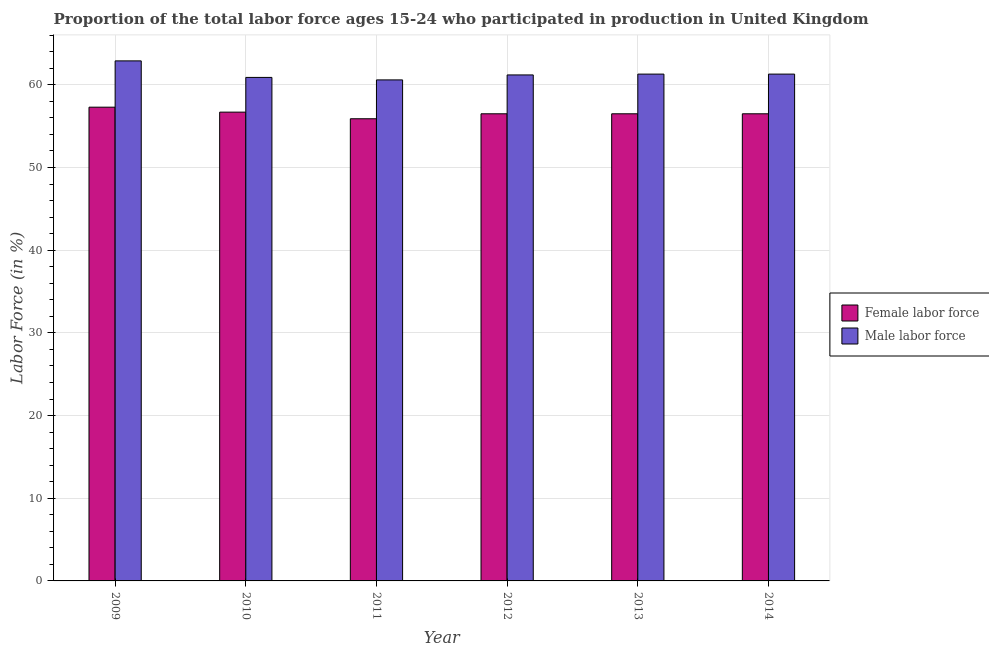How many different coloured bars are there?
Provide a short and direct response. 2. How many bars are there on the 2nd tick from the right?
Provide a short and direct response. 2. In how many cases, is the number of bars for a given year not equal to the number of legend labels?
Provide a succinct answer. 0. What is the percentage of male labour force in 2013?
Offer a very short reply. 61.3. Across all years, what is the maximum percentage of female labor force?
Your answer should be compact. 57.3. Across all years, what is the minimum percentage of female labor force?
Provide a succinct answer. 55.9. What is the total percentage of male labour force in the graph?
Give a very brief answer. 368.2. What is the difference between the percentage of male labour force in 2010 and that in 2013?
Provide a succinct answer. -0.4. What is the difference between the percentage of female labor force in 2011 and the percentage of male labour force in 2009?
Offer a terse response. -1.4. What is the average percentage of female labor force per year?
Keep it short and to the point. 56.57. What is the ratio of the percentage of female labor force in 2011 to that in 2012?
Provide a short and direct response. 0.99. Is the percentage of male labour force in 2009 less than that in 2012?
Provide a succinct answer. No. Is the difference between the percentage of female labor force in 2011 and 2014 greater than the difference between the percentage of male labour force in 2011 and 2014?
Keep it short and to the point. No. What is the difference between the highest and the second highest percentage of female labor force?
Offer a very short reply. 0.6. What is the difference between the highest and the lowest percentage of female labor force?
Your answer should be compact. 1.4. Is the sum of the percentage of female labor force in 2010 and 2011 greater than the maximum percentage of male labour force across all years?
Provide a succinct answer. Yes. What does the 1st bar from the left in 2010 represents?
Offer a very short reply. Female labor force. What does the 1st bar from the right in 2010 represents?
Your response must be concise. Male labor force. How many bars are there?
Make the answer very short. 12. What is the difference between two consecutive major ticks on the Y-axis?
Your response must be concise. 10. Where does the legend appear in the graph?
Ensure brevity in your answer.  Center right. How many legend labels are there?
Your answer should be very brief. 2. What is the title of the graph?
Offer a very short reply. Proportion of the total labor force ages 15-24 who participated in production in United Kingdom. Does "Lowest 20% of population" appear as one of the legend labels in the graph?
Offer a very short reply. No. What is the label or title of the X-axis?
Your answer should be compact. Year. What is the Labor Force (in %) of Female labor force in 2009?
Make the answer very short. 57.3. What is the Labor Force (in %) of Male labor force in 2009?
Make the answer very short. 62.9. What is the Labor Force (in %) of Female labor force in 2010?
Give a very brief answer. 56.7. What is the Labor Force (in %) in Male labor force in 2010?
Provide a succinct answer. 60.9. What is the Labor Force (in %) of Female labor force in 2011?
Your response must be concise. 55.9. What is the Labor Force (in %) of Male labor force in 2011?
Offer a terse response. 60.6. What is the Labor Force (in %) of Female labor force in 2012?
Provide a succinct answer. 56.5. What is the Labor Force (in %) of Male labor force in 2012?
Your answer should be very brief. 61.2. What is the Labor Force (in %) of Female labor force in 2013?
Ensure brevity in your answer.  56.5. What is the Labor Force (in %) of Male labor force in 2013?
Ensure brevity in your answer.  61.3. What is the Labor Force (in %) of Female labor force in 2014?
Offer a very short reply. 56.5. What is the Labor Force (in %) of Male labor force in 2014?
Ensure brevity in your answer.  61.3. Across all years, what is the maximum Labor Force (in %) in Female labor force?
Offer a very short reply. 57.3. Across all years, what is the maximum Labor Force (in %) of Male labor force?
Provide a succinct answer. 62.9. Across all years, what is the minimum Labor Force (in %) of Female labor force?
Make the answer very short. 55.9. Across all years, what is the minimum Labor Force (in %) of Male labor force?
Your response must be concise. 60.6. What is the total Labor Force (in %) in Female labor force in the graph?
Provide a succinct answer. 339.4. What is the total Labor Force (in %) in Male labor force in the graph?
Provide a succinct answer. 368.2. What is the difference between the Labor Force (in %) of Female labor force in 2009 and that in 2010?
Your response must be concise. 0.6. What is the difference between the Labor Force (in %) in Male labor force in 2009 and that in 2010?
Your answer should be compact. 2. What is the difference between the Labor Force (in %) of Male labor force in 2009 and that in 2011?
Keep it short and to the point. 2.3. What is the difference between the Labor Force (in %) of Female labor force in 2009 and that in 2014?
Make the answer very short. 0.8. What is the difference between the Labor Force (in %) of Male labor force in 2009 and that in 2014?
Ensure brevity in your answer.  1.6. What is the difference between the Labor Force (in %) in Female labor force in 2010 and that in 2011?
Your response must be concise. 0.8. What is the difference between the Labor Force (in %) in Male labor force in 2010 and that in 2011?
Your answer should be very brief. 0.3. What is the difference between the Labor Force (in %) in Male labor force in 2010 and that in 2012?
Provide a short and direct response. -0.3. What is the difference between the Labor Force (in %) of Female labor force in 2010 and that in 2013?
Your answer should be very brief. 0.2. What is the difference between the Labor Force (in %) of Male labor force in 2010 and that in 2013?
Your answer should be very brief. -0.4. What is the difference between the Labor Force (in %) of Male labor force in 2011 and that in 2012?
Provide a succinct answer. -0.6. What is the difference between the Labor Force (in %) of Female labor force in 2012 and that in 2013?
Your response must be concise. 0. What is the difference between the Labor Force (in %) in Male labor force in 2012 and that in 2013?
Your answer should be compact. -0.1. What is the difference between the Labor Force (in %) in Female labor force in 2012 and that in 2014?
Offer a terse response. 0. What is the difference between the Labor Force (in %) in Male labor force in 2012 and that in 2014?
Your answer should be very brief. -0.1. What is the difference between the Labor Force (in %) in Male labor force in 2013 and that in 2014?
Offer a very short reply. 0. What is the difference between the Labor Force (in %) of Female labor force in 2009 and the Labor Force (in %) of Male labor force in 2010?
Ensure brevity in your answer.  -3.6. What is the difference between the Labor Force (in %) in Female labor force in 2009 and the Labor Force (in %) in Male labor force in 2014?
Give a very brief answer. -4. What is the difference between the Labor Force (in %) in Female labor force in 2010 and the Labor Force (in %) in Male labor force in 2011?
Offer a terse response. -3.9. What is the difference between the Labor Force (in %) of Female labor force in 2010 and the Labor Force (in %) of Male labor force in 2012?
Your answer should be compact. -4.5. What is the difference between the Labor Force (in %) of Female labor force in 2011 and the Labor Force (in %) of Male labor force in 2012?
Keep it short and to the point. -5.3. What is the difference between the Labor Force (in %) in Female labor force in 2011 and the Labor Force (in %) in Male labor force in 2013?
Your answer should be compact. -5.4. What is the difference between the Labor Force (in %) in Female labor force in 2012 and the Labor Force (in %) in Male labor force in 2013?
Provide a succinct answer. -4.8. What is the difference between the Labor Force (in %) in Female labor force in 2012 and the Labor Force (in %) in Male labor force in 2014?
Your answer should be very brief. -4.8. What is the average Labor Force (in %) in Female labor force per year?
Your answer should be compact. 56.57. What is the average Labor Force (in %) of Male labor force per year?
Ensure brevity in your answer.  61.37. In the year 2009, what is the difference between the Labor Force (in %) in Female labor force and Labor Force (in %) in Male labor force?
Keep it short and to the point. -5.6. In the year 2010, what is the difference between the Labor Force (in %) of Female labor force and Labor Force (in %) of Male labor force?
Make the answer very short. -4.2. What is the ratio of the Labor Force (in %) of Female labor force in 2009 to that in 2010?
Ensure brevity in your answer.  1.01. What is the ratio of the Labor Force (in %) in Male labor force in 2009 to that in 2010?
Make the answer very short. 1.03. What is the ratio of the Labor Force (in %) of Female labor force in 2009 to that in 2011?
Your answer should be very brief. 1.02. What is the ratio of the Labor Force (in %) of Male labor force in 2009 to that in 2011?
Offer a terse response. 1.04. What is the ratio of the Labor Force (in %) in Female labor force in 2009 to that in 2012?
Your answer should be very brief. 1.01. What is the ratio of the Labor Force (in %) of Male labor force in 2009 to that in 2012?
Your answer should be compact. 1.03. What is the ratio of the Labor Force (in %) of Female labor force in 2009 to that in 2013?
Give a very brief answer. 1.01. What is the ratio of the Labor Force (in %) of Male labor force in 2009 to that in 2013?
Give a very brief answer. 1.03. What is the ratio of the Labor Force (in %) of Female labor force in 2009 to that in 2014?
Provide a short and direct response. 1.01. What is the ratio of the Labor Force (in %) of Male labor force in 2009 to that in 2014?
Provide a succinct answer. 1.03. What is the ratio of the Labor Force (in %) in Female labor force in 2010 to that in 2011?
Your response must be concise. 1.01. What is the ratio of the Labor Force (in %) of Female labor force in 2010 to that in 2012?
Provide a short and direct response. 1. What is the ratio of the Labor Force (in %) in Male labor force in 2010 to that in 2012?
Make the answer very short. 1. What is the ratio of the Labor Force (in %) of Female labor force in 2010 to that in 2013?
Offer a terse response. 1. What is the ratio of the Labor Force (in %) of Male labor force in 2010 to that in 2014?
Give a very brief answer. 0.99. What is the ratio of the Labor Force (in %) in Female labor force in 2011 to that in 2012?
Provide a short and direct response. 0.99. What is the ratio of the Labor Force (in %) of Male labor force in 2011 to that in 2012?
Provide a succinct answer. 0.99. What is the ratio of the Labor Force (in %) in Male labor force in 2011 to that in 2013?
Ensure brevity in your answer.  0.99. What is the ratio of the Labor Force (in %) in Female labor force in 2011 to that in 2014?
Offer a terse response. 0.99. What is the ratio of the Labor Force (in %) in Male labor force in 2011 to that in 2014?
Offer a terse response. 0.99. What is the ratio of the Labor Force (in %) in Female labor force in 2012 to that in 2013?
Offer a terse response. 1. What is the ratio of the Labor Force (in %) in Male labor force in 2012 to that in 2013?
Ensure brevity in your answer.  1. What is the ratio of the Labor Force (in %) in Female labor force in 2012 to that in 2014?
Give a very brief answer. 1. What is the ratio of the Labor Force (in %) in Female labor force in 2013 to that in 2014?
Keep it short and to the point. 1. What is the ratio of the Labor Force (in %) of Male labor force in 2013 to that in 2014?
Keep it short and to the point. 1. What is the difference between the highest and the lowest Labor Force (in %) in Male labor force?
Provide a short and direct response. 2.3. 